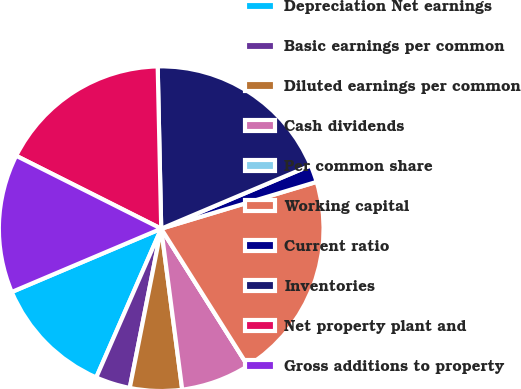<chart> <loc_0><loc_0><loc_500><loc_500><pie_chart><fcel>Depreciation Net earnings<fcel>Basic earnings per common<fcel>Diluted earnings per common<fcel>Cash dividends<fcel>Per common share<fcel>Working capital<fcel>Current ratio<fcel>Inventories<fcel>Net property plant and<fcel>Gross additions to property<nl><fcel>12.07%<fcel>3.45%<fcel>5.17%<fcel>6.9%<fcel>0.0%<fcel>20.69%<fcel>1.72%<fcel>18.97%<fcel>17.24%<fcel>13.79%<nl></chart> 